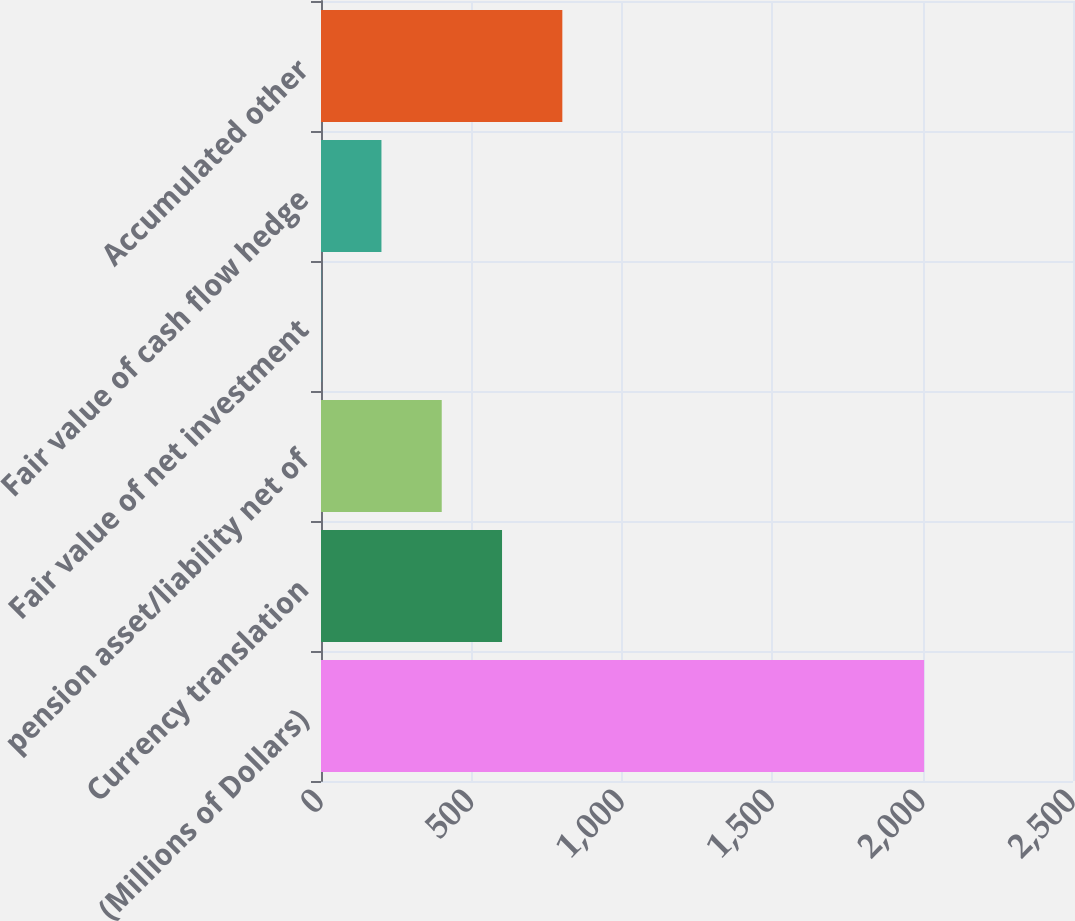Convert chart. <chart><loc_0><loc_0><loc_500><loc_500><bar_chart><fcel>(Millions of Dollars)<fcel>Currency translation<fcel>pension asset/liability net of<fcel>Fair value of net investment<fcel>Fair value of cash flow hedge<fcel>Accumulated other<nl><fcel>2005<fcel>601.85<fcel>401.4<fcel>0.5<fcel>200.95<fcel>802.3<nl></chart> 